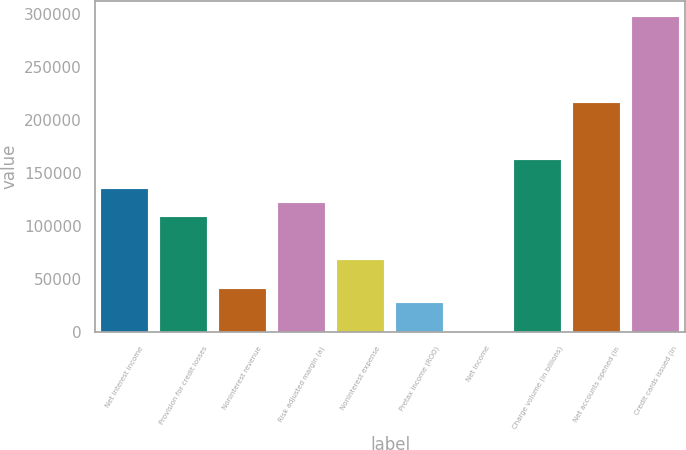Convert chart to OTSL. <chart><loc_0><loc_0><loc_500><loc_500><bar_chart><fcel>Net interest income<fcel>Provision for credit losses<fcel>Noninterest revenue<fcel>Risk adjusted margin (a)<fcel>Noninterest expense<fcel>Pretax income (ROO)<fcel>Net income<fcel>Charge volume (in billions)<fcel>Net accounts opened (in<fcel>Credit cards issued (in<nl><fcel>135370<fcel>108296<fcel>40612<fcel>121833<fcel>67685.7<fcel>27075.1<fcel>1.39<fcel>162444<fcel>216591<fcel>297812<nl></chart> 